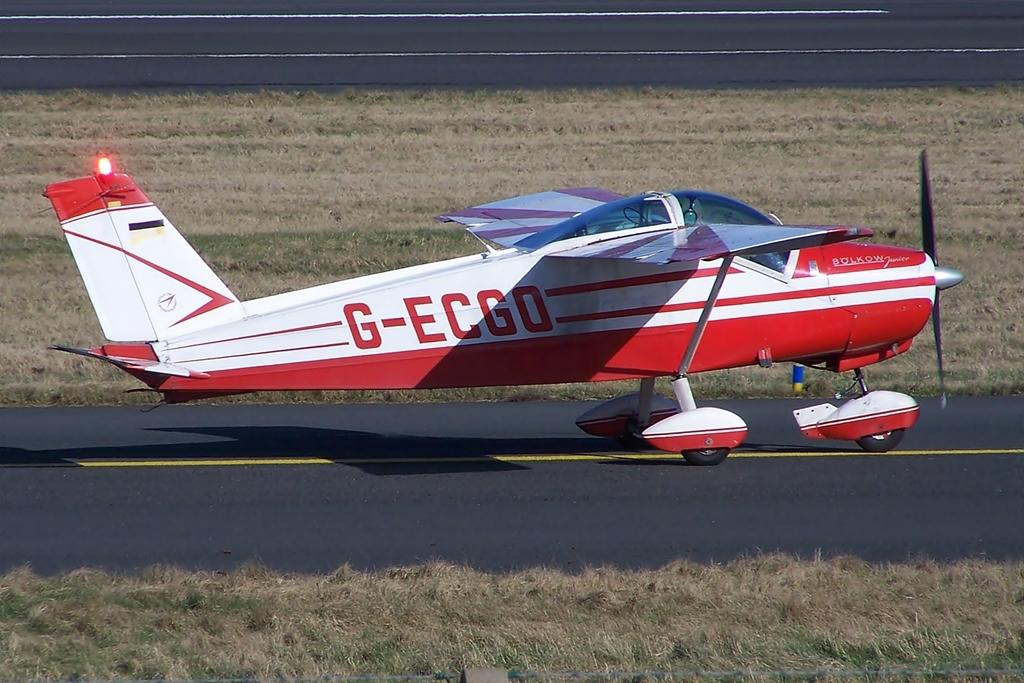<image>
Render a clear and concise summary of the photo. A small prop plane has the call letters G-ECGO on the side. 